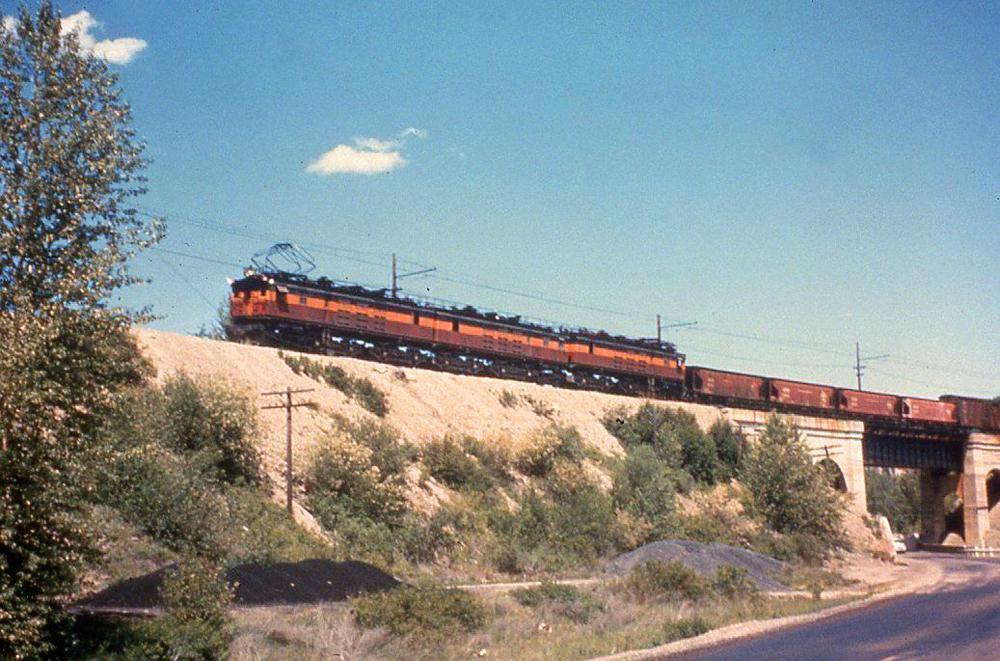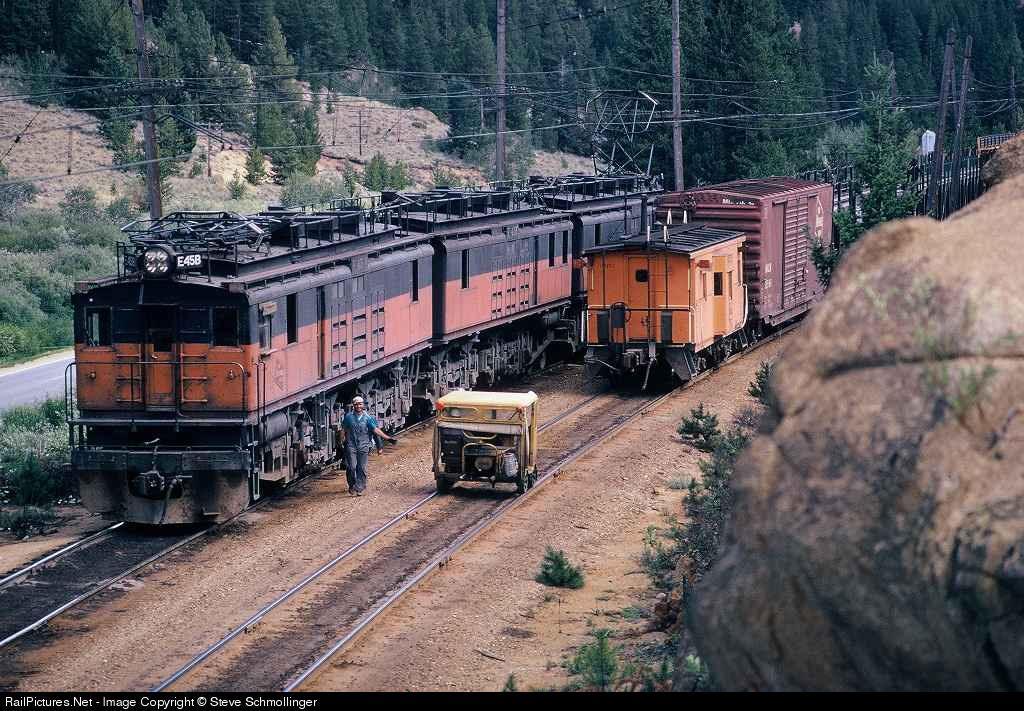The first image is the image on the left, the second image is the image on the right. Examine the images to the left and right. Is the description "At least one of the trains is painted with the bottom half orange, and the top half brown." accurate? Answer yes or no. Yes. 